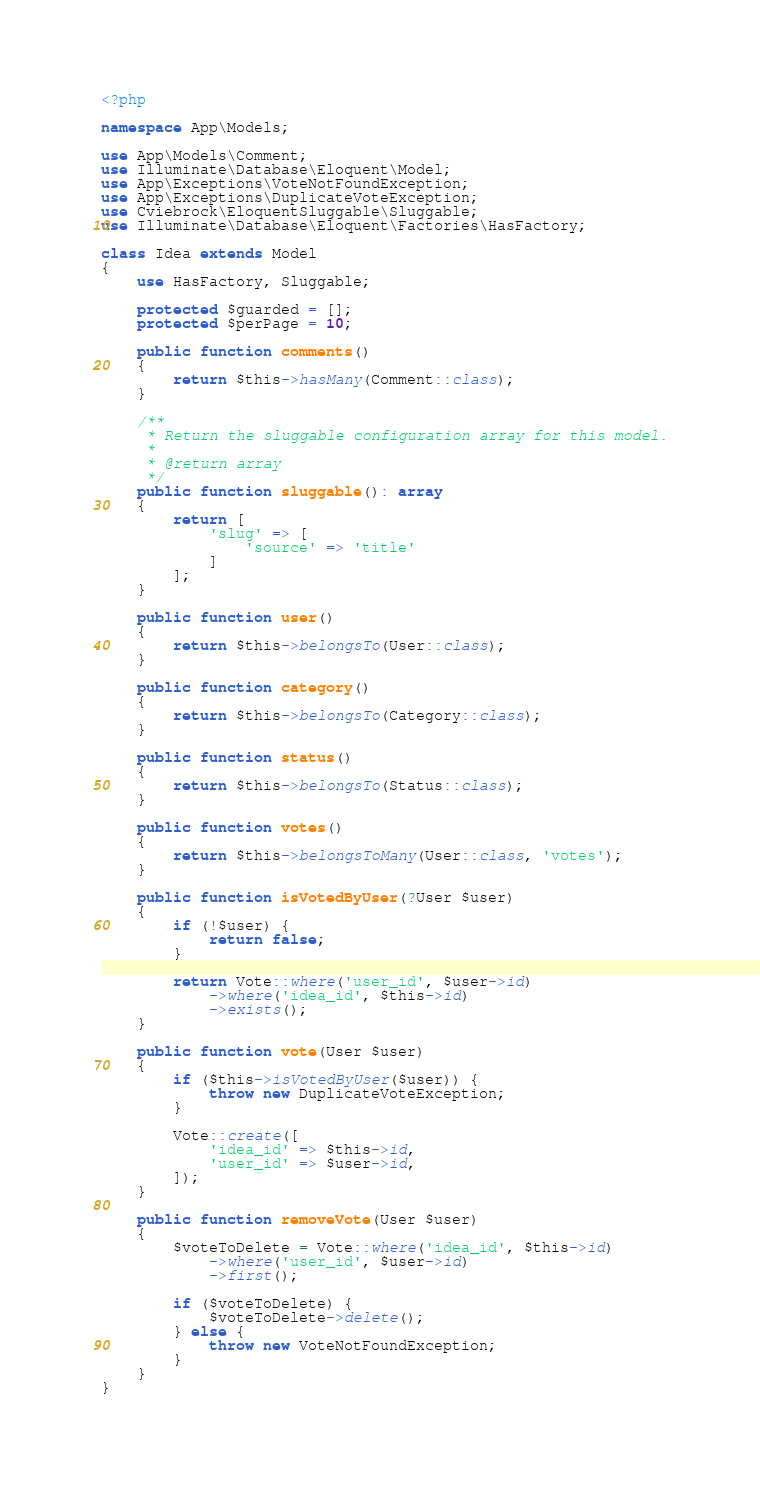<code> <loc_0><loc_0><loc_500><loc_500><_PHP_><?php

namespace App\Models;

use App\Models\Comment;
use Illuminate\Database\Eloquent\Model;
use App\Exceptions\VoteNotFoundException;
use App\Exceptions\DuplicateVoteException;
use Cviebrock\EloquentSluggable\Sluggable;
use Illuminate\Database\Eloquent\Factories\HasFactory;

class Idea extends Model
{
    use HasFactory, Sluggable;

    protected $guarded = [];
    protected $perPage = 10;

    public function comments()
    {
        return $this->hasMany(Comment::class);
    }

    /**
     * Return the sluggable configuration array for this model.
     *
     * @return array
     */
    public function sluggable(): array
    {
        return [
            'slug' => [
                'source' => 'title'
            ]
        ];
    }

    public function user()
    {
        return $this->belongsTo(User::class);
    }

    public function category()
    {
        return $this->belongsTo(Category::class);
    }

    public function status()
    {
        return $this->belongsTo(Status::class);
    }

    public function votes()
    {
        return $this->belongsToMany(User::class, 'votes');
    }

    public function isVotedByUser(?User $user)
    {
        if (!$user) {
            return false;
        }

        return Vote::where('user_id', $user->id)
            ->where('idea_id', $this->id)
            ->exists();
    }

    public function vote(User $user)
    {
        if ($this->isVotedByUser($user)) {
            throw new DuplicateVoteException;
        }

        Vote::create([
            'idea_id' => $this->id,
            'user_id' => $user->id,
        ]);
    }

    public function removeVote(User $user)
    {
        $voteToDelete = Vote::where('idea_id', $this->id)
            ->where('user_id', $user->id)
            ->first();

        if ($voteToDelete) {
            $voteToDelete->delete();
        } else {
            throw new VoteNotFoundException;
        }
    }
}
</code> 